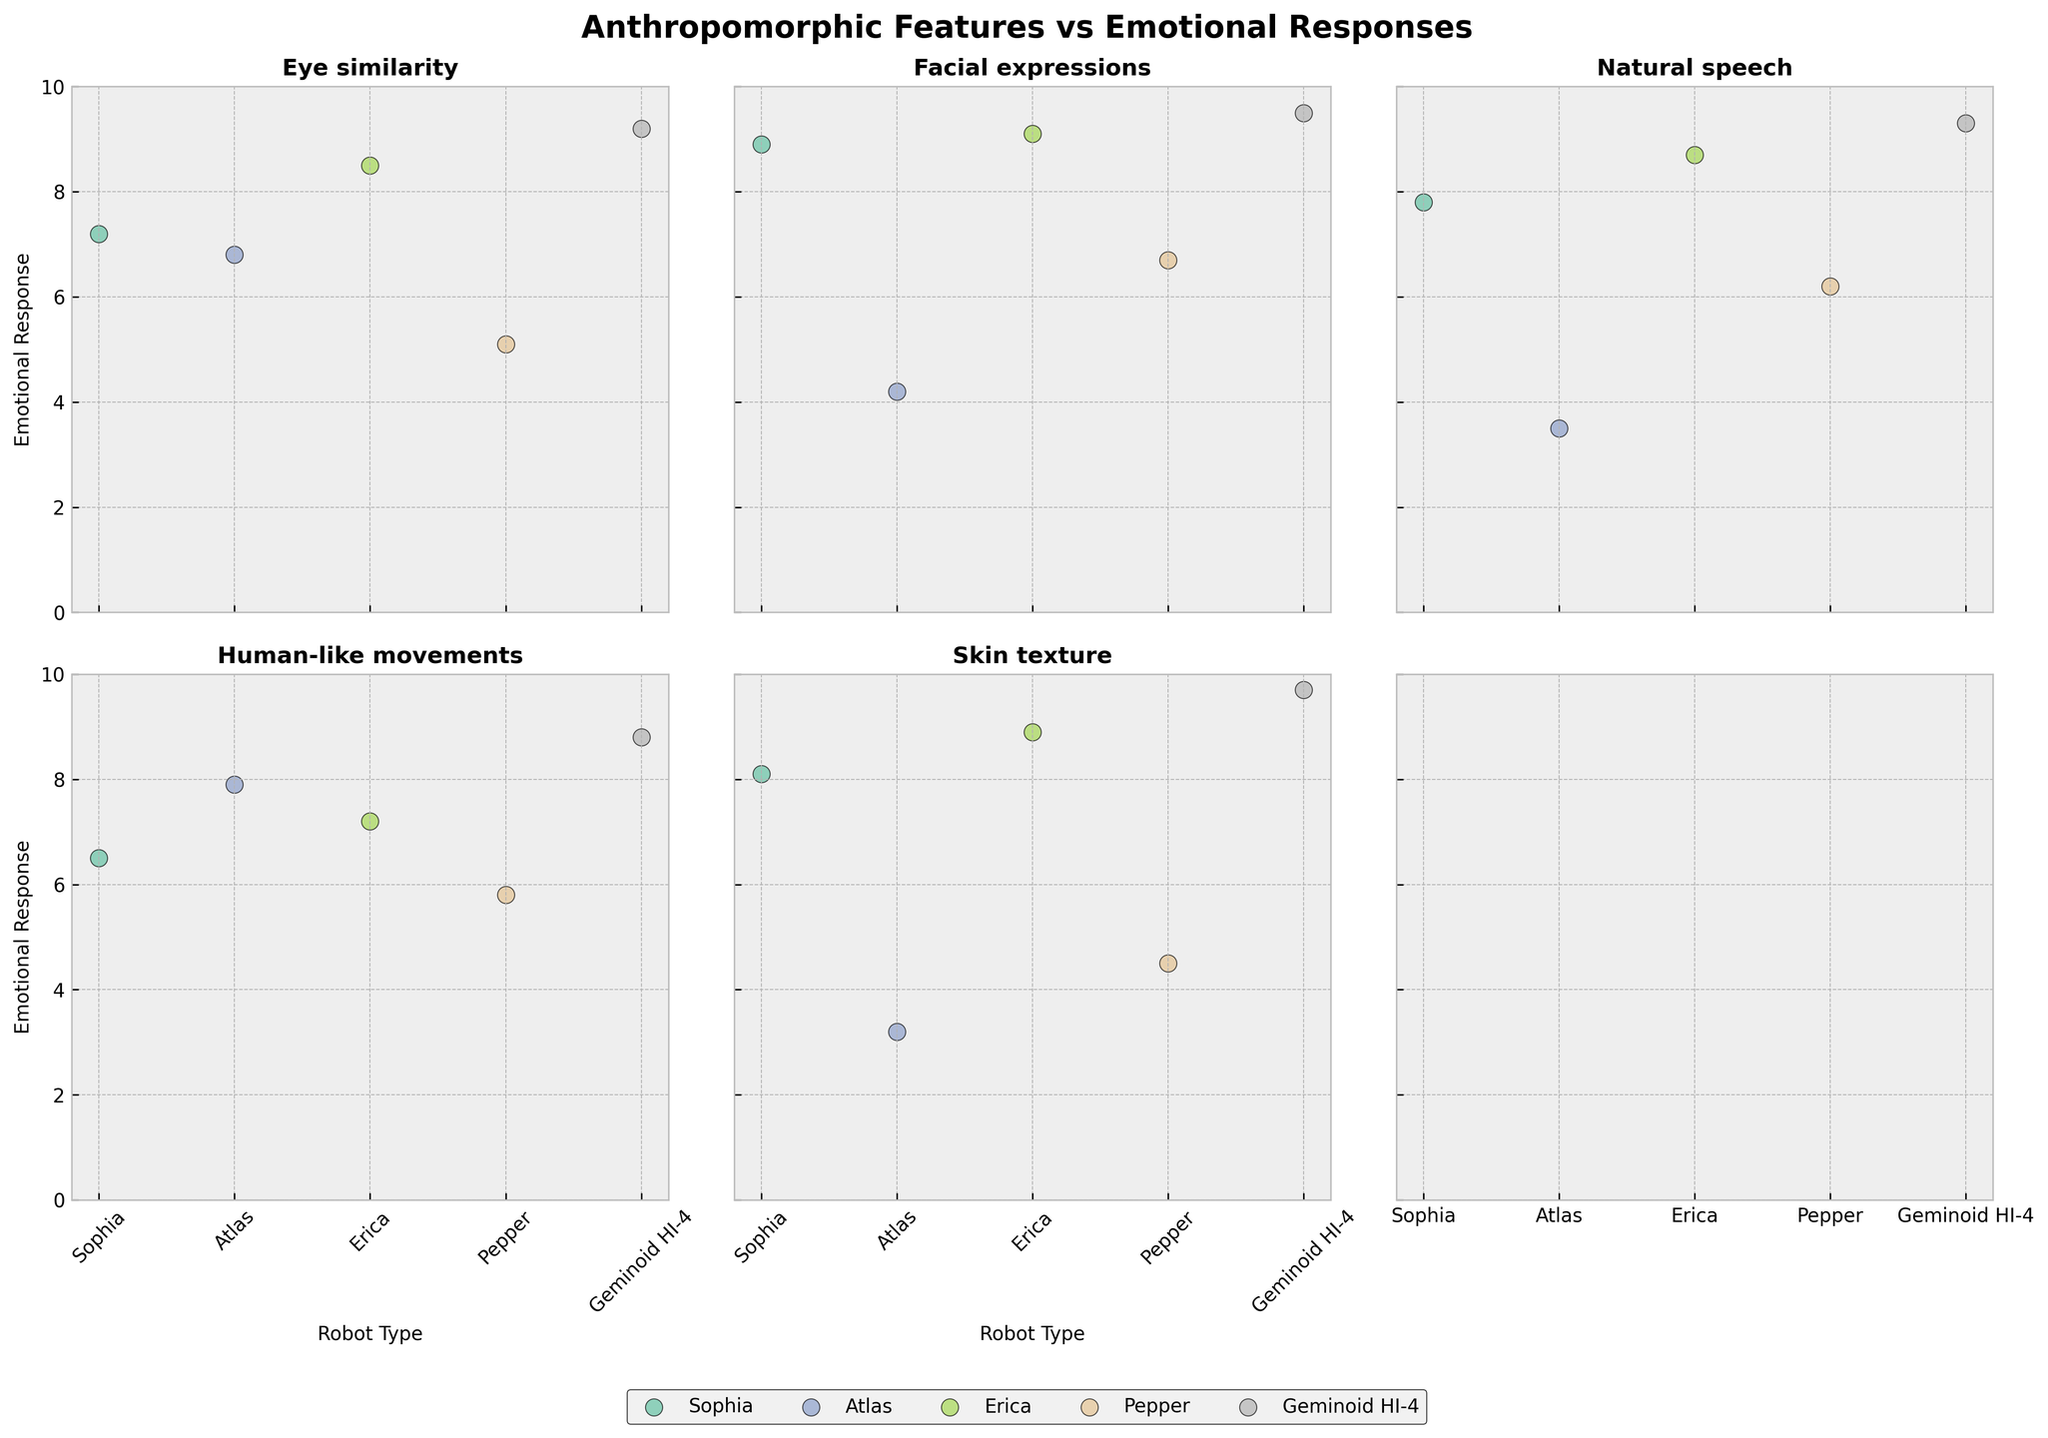What is the title of the figure? The title is usually displayed at the top of the figure. In this plot, it is 'Anthropomorphic Features vs Emotional Responses'.
Answer: Anthropomorphic Features vs Emotional Responses How many robots are being compared in the figure? By observing the different markers in each subplot, it is evident that there are five robots: Sophia, Atlas, Erica, Pepper, and Geminoid HI-4.
Answer: 5 Which robot has the highest emotional response for 'Natural speech'? In the subplot corresponding to 'Natural speech', the dot representing the highest emotional response is Geminoid HI-4, as it is the most elevated point.
Answer: Geminoid HI-4 What is the emotional response score for Atlas's 'Skin texture'? In the 'Skin texture' subplot, locate the Atlas marker and observe its position on the y-axis. The score is 3.2.
Answer: 3.2 Which robot-type has the lowest emotional response for 'Facial expressions'? In the subplot for 'Facial expressions', the lowest point on the y-axis corresponds to Atlas.
Answer: Atlas What is the difference in emotional response for 'Eye similarity' between Erica and Pepper? In the 'Eye similarity' subplot, Erica's emotional response is 8.5 and Pepper's is 5.1. The difference is 8.5 - 5.1 = 3.4.
Answer: 3.4 Which anthropomorphic feature has the closest emotional responses among all robots? Observing all subplots, 'Human-like movements' appear to have the closest emotional responses, as the values range between 5.8 and 8.8, showing relatively smaller variations.
Answer: Human-like movements Compare Sophia and Erica across all features. For how many features does Erica have a higher emotional response than Sophia? Comparing both robots in each subplot: 
'Eye similarity': Erica (8.5) > Sophia (7.2)
'Facial expressions': Erica (9.1) > Sophia (8.9)
'Natural speech': Erica (8.7) > Sophia (7.8)
'Human-like movements': Erica (7.2) > Sophia (6.5)
'Skin texture': Erica (8.9) > Sophia (8.1)
Erica has a higher emotional response in all the compared features (5 out of 5).
Answer: 5 Among the robots, who shows the biggest disparity in emotional response between anthropomorphic features 'Natural speech' and 'Skin texture'? Looking at the subplots for 'Natural speech' and 'Skin texture', Atlas shows the biggest disparity with an emotional response of 3.5 for 'Natural speech' and 3.2 for 'Skin texture', a difference of 0.3. For other robots, the differences are larger.
Answer: Atlas 